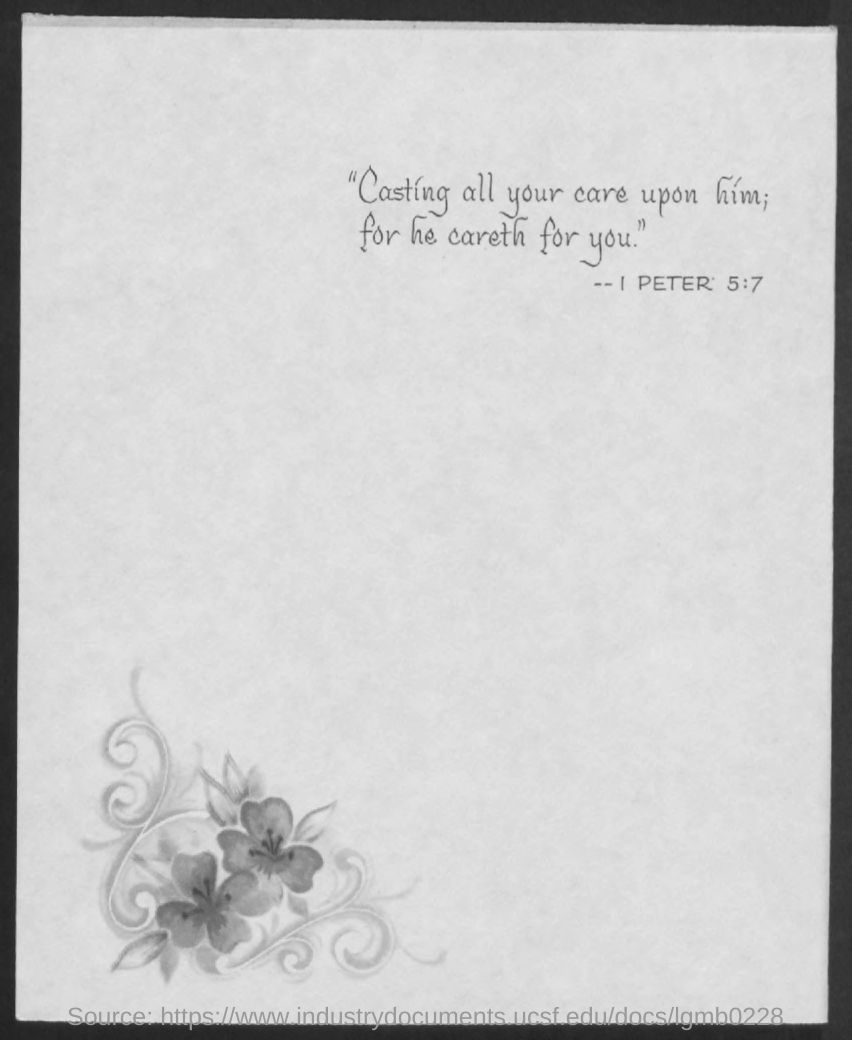Outline some significant characteristics in this image. The document mentions 1 Peter 5:7 as a Bible verse. 